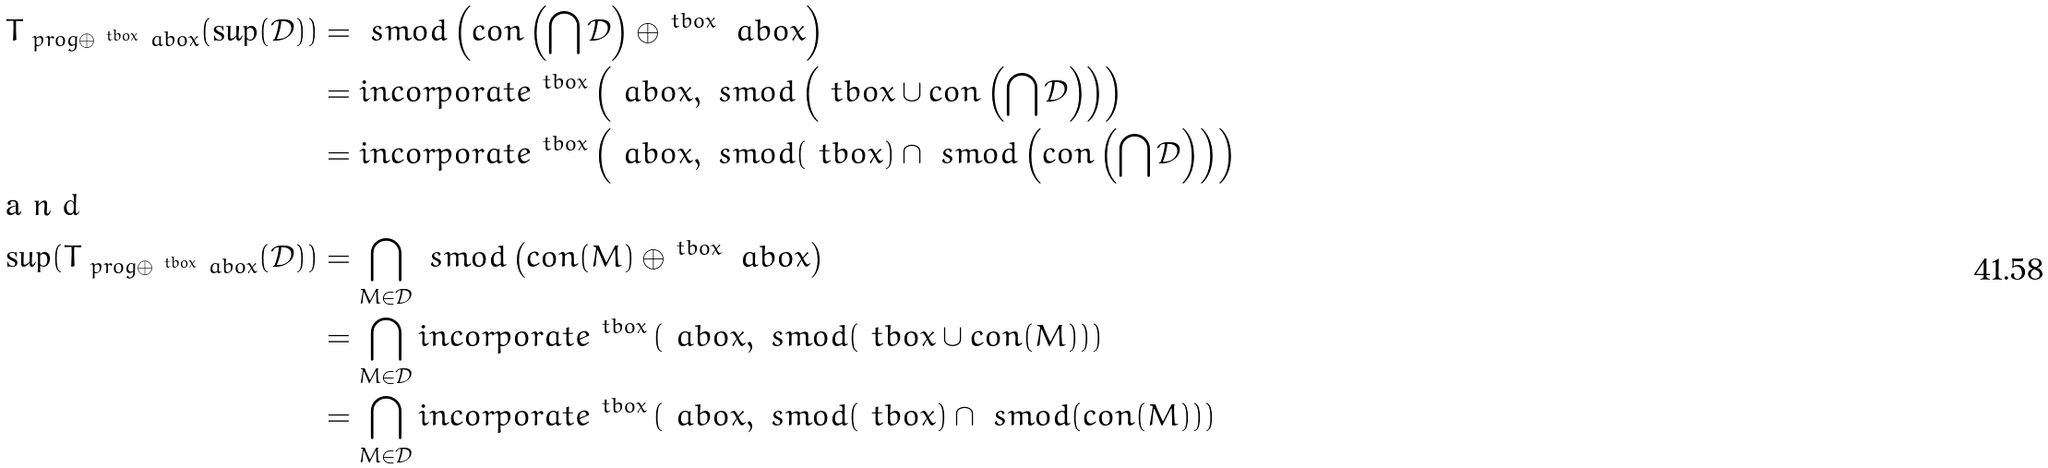Convert formula to latex. <formula><loc_0><loc_0><loc_500><loc_500>T _ { \ p r o g \oplus ^ { \ t b o x } \ a b o x } ( \sup ( \mathcal { D } ) ) & = \ s m o d \left ( c o n \left ( \bigcap \mathcal { D } \right ) \oplus ^ { \ t b o x } \ a b o x \right ) \\ & = i n c o r p o r a t e ^ { \ t b o x } \left ( \ a b o x , \ s m o d \left ( \ t b o x \cup c o n \left ( \bigcap \mathcal { D } \right ) \right ) \right ) \\ & = i n c o r p o r a t e ^ { \ t b o x } \left ( \ a b o x , \ s m o d ( \ t b o x ) \cap \ s m o d \left ( c o n \left ( \bigcap \mathcal { D } \right ) \right ) \right ) \\ \intertext { a n d } \sup ( T _ { \ p r o g \oplus ^ { \ t b o x } \ a b o x } ( \mathcal { D } ) ) & = \bigcap _ { M \in \mathcal { D } } \ s m o d \left ( c o n ( M ) \oplus ^ { \ t b o x } \ a b o x \right ) \\ & = \bigcap _ { M \in \mathcal { D } } i n c o r p o r a t e ^ { \ t b o x } \left ( \ a b o x , \ s m o d ( \ t b o x \cup c o n ( M ) ) \right ) \\ & = \bigcap _ { M \in \mathcal { D } } i n c o r p o r a t e ^ { \ t b o x } \left ( \ a b o x , \ s m o d ( \ t b o x ) \cap \ s m o d ( c o n ( M ) ) \right )</formula> 